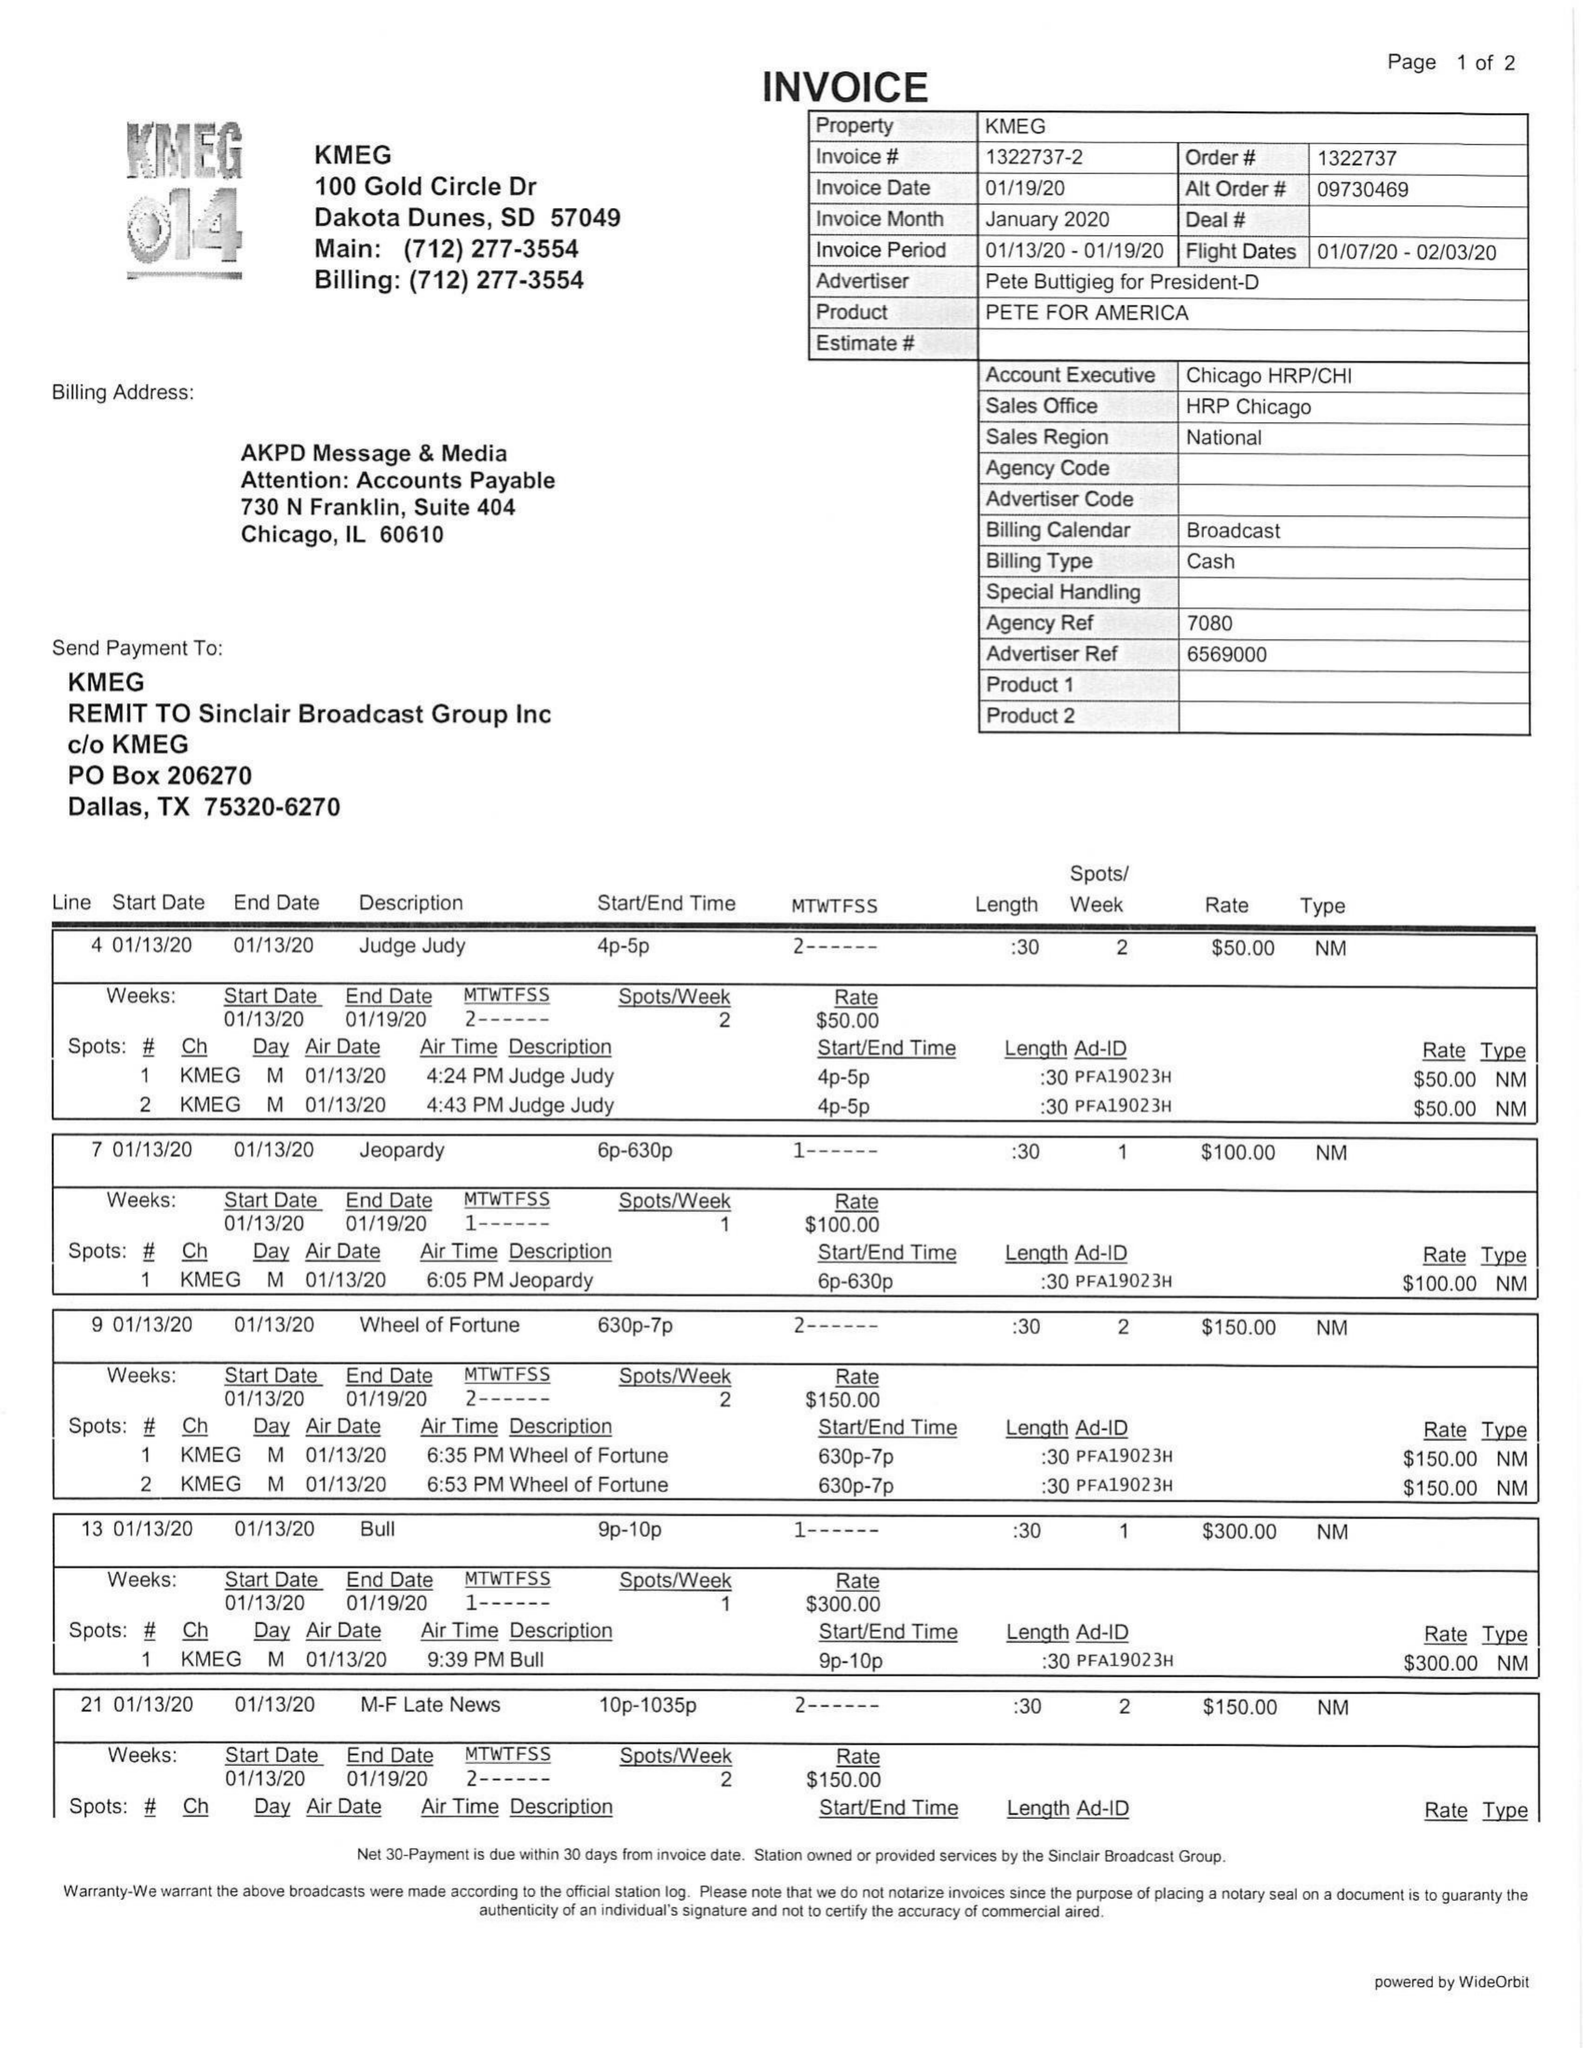What is the value for the gross_amount?
Answer the question using a single word or phrase. 1250.00 